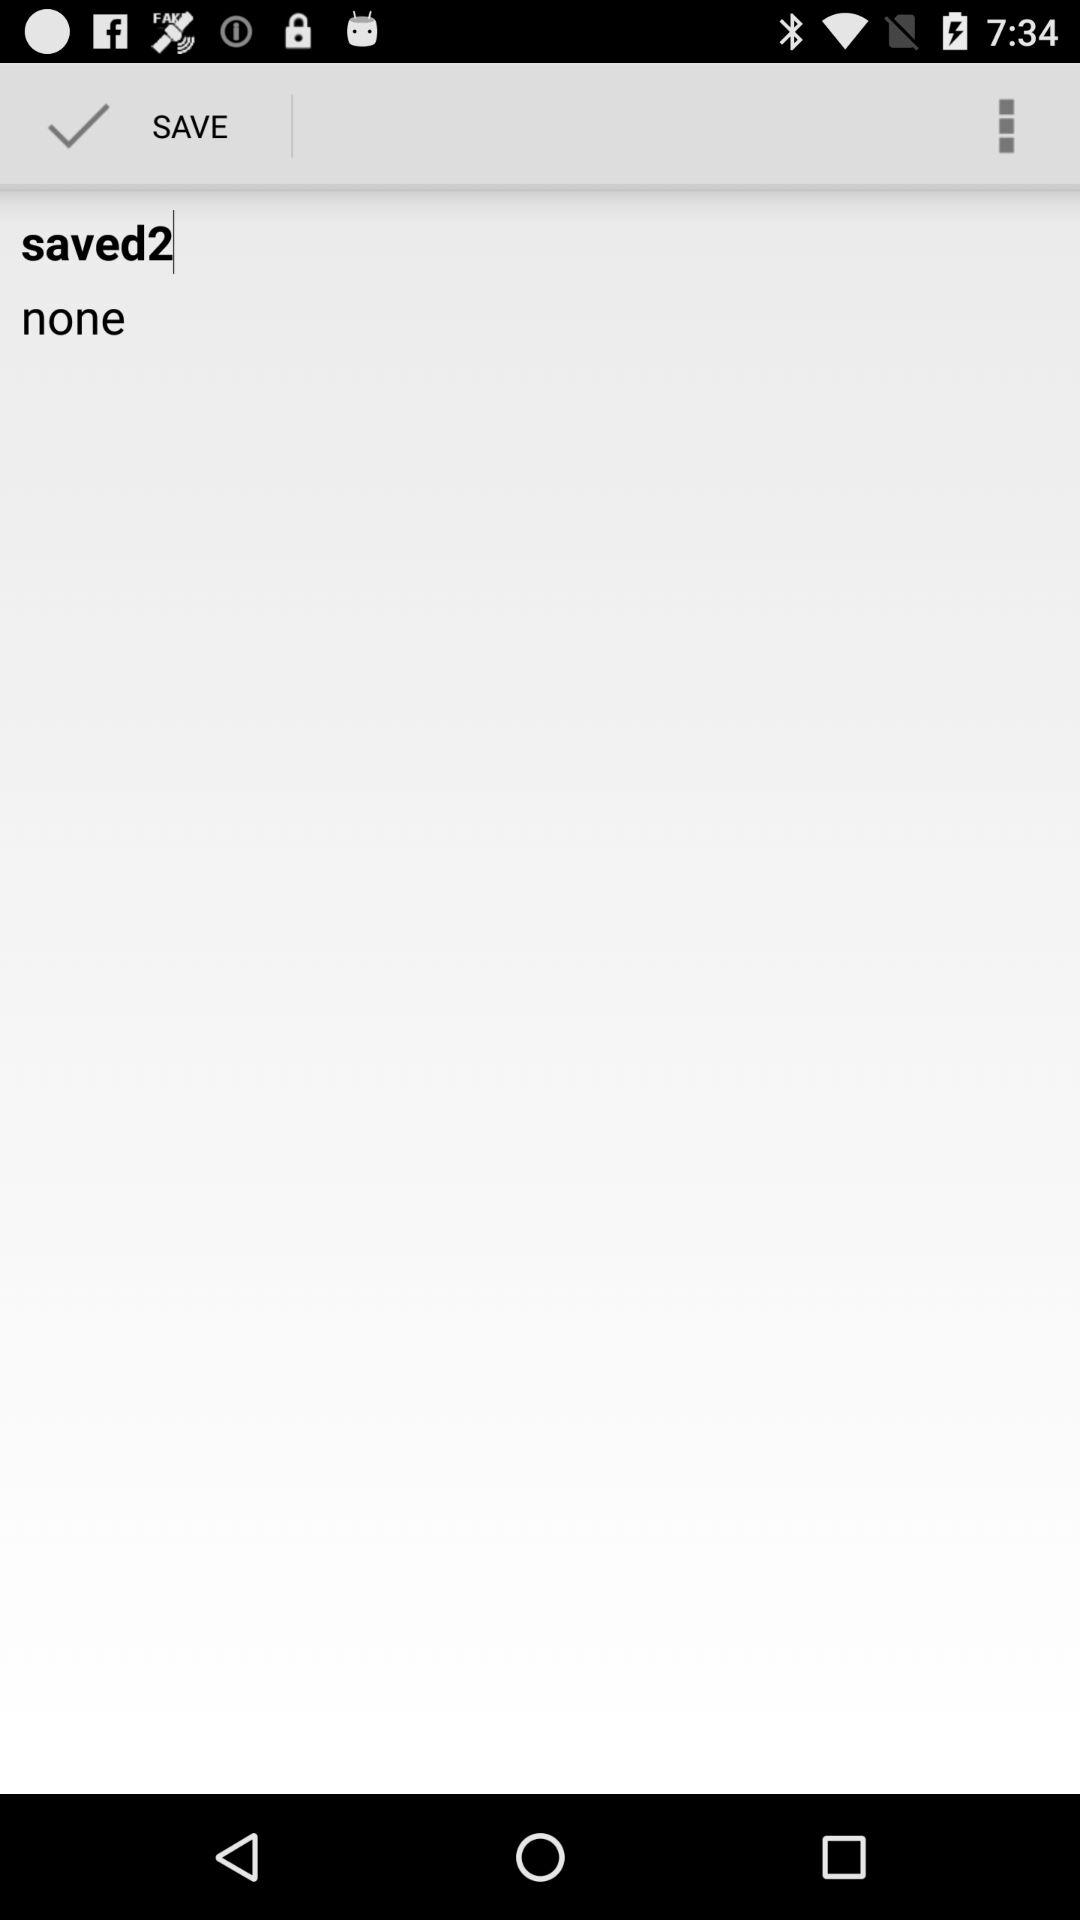How many text elements are there that are not saved?
Answer the question using a single word or phrase. 1 